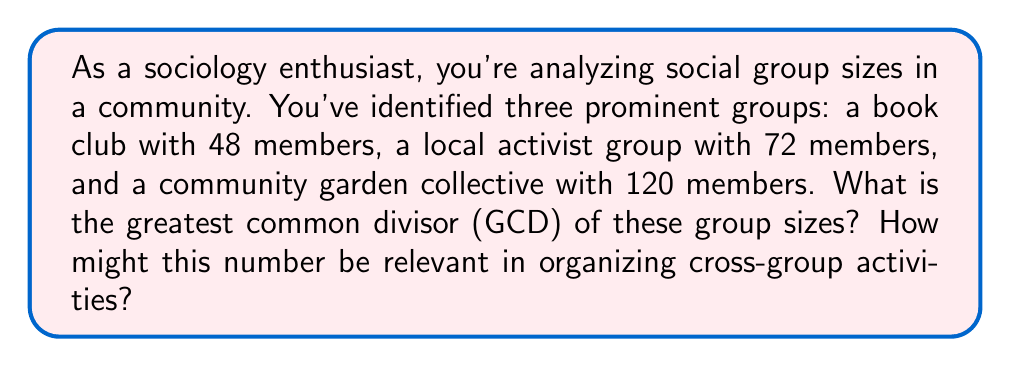Solve this math problem. To solve this problem, we need to find the greatest common divisor (GCD) of 48, 72, and 120. We can use the Euclidean algorithm repeatedly:

1) First, let's find the GCD of 48 and 72:
   $72 = 1 \times 48 + 24$
   $48 = 2 \times 24 + 0$
   Therefore, $GCD(48, 72) = 24$

2) Now, let's find the GCD of 24 and 120:
   $120 = 5 \times 24 + 0$
   Therefore, $GCD(24, 120) = 24$

3) Since $GCD(48, 72) = 24$ and $GCD(24, 120) = 24$, we can conclude that the GCD of all three numbers is 24.

We can verify this result:
$48 = 2 \times 24$
$72 = 3 \times 24$
$120 = 5 \times 24$

The significance of this result in a sociological context is that 24 represents the largest subgroup size that could be formed with equal numbers from each of the three groups. This could be useful for organizing cross-group activities or forming mixed committees with equal representation from each group.
Answer: The greatest common divisor of the social group sizes (48, 72, and 120) is 24. 